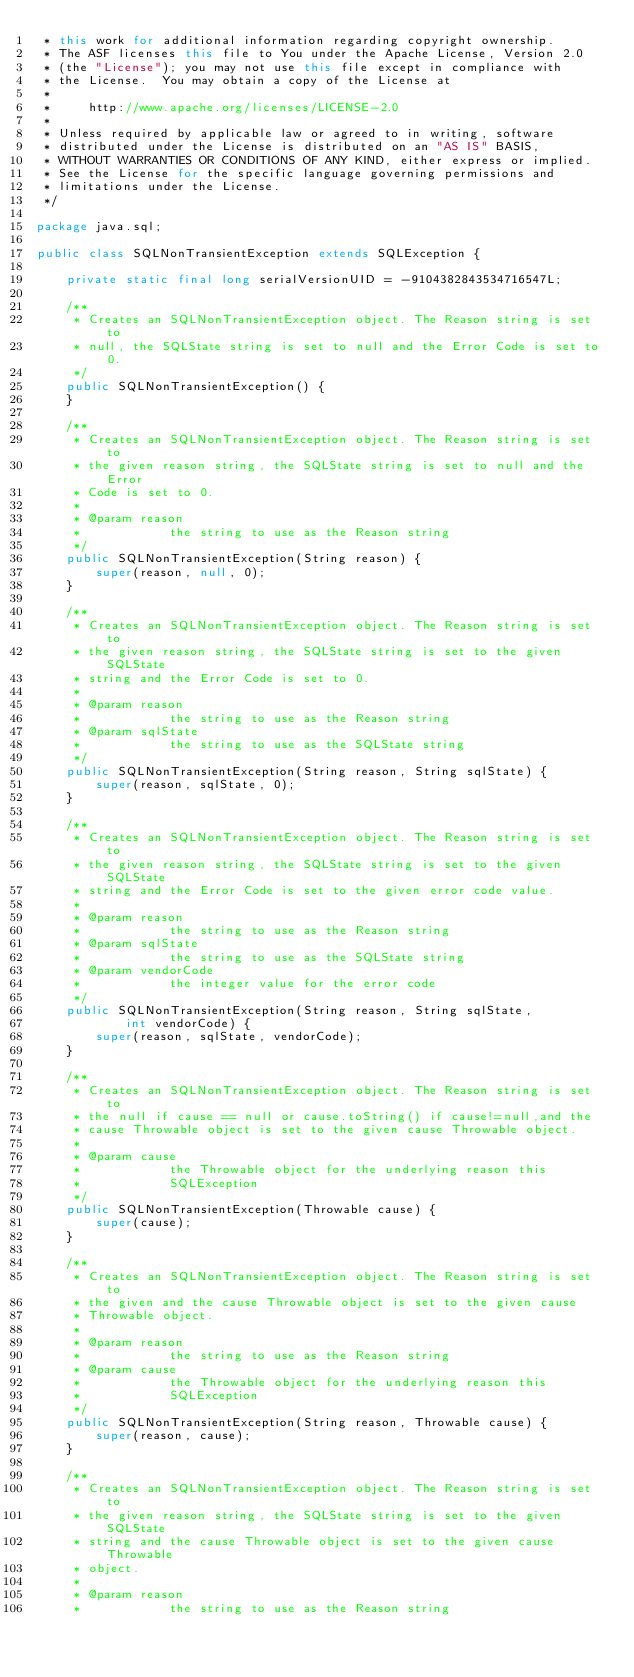<code> <loc_0><loc_0><loc_500><loc_500><_Java_> * this work for additional information regarding copyright ownership.
 * The ASF licenses this file to You under the Apache License, Version 2.0
 * (the "License"); you may not use this file except in compliance with
 * the License.  You may obtain a copy of the License at
 *
 *     http://www.apache.org/licenses/LICENSE-2.0
 *
 * Unless required by applicable law or agreed to in writing, software
 * distributed under the License is distributed on an "AS IS" BASIS,
 * WITHOUT WARRANTIES OR CONDITIONS OF ANY KIND, either express or implied.
 * See the License for the specific language governing permissions and
 * limitations under the License.
 */

package java.sql;

public class SQLNonTransientException extends SQLException {

    private static final long serialVersionUID = -9104382843534716547L;

    /**
     * Creates an SQLNonTransientException object. The Reason string is set to
     * null, the SQLState string is set to null and the Error Code is set to 0.
     */
    public SQLNonTransientException() {
    }

    /**
     * Creates an SQLNonTransientException object. The Reason string is set to
     * the given reason string, the SQLState string is set to null and the Error
     * Code is set to 0.
     *
     * @param reason
     *            the string to use as the Reason string
     */
    public SQLNonTransientException(String reason) {
        super(reason, null, 0);
    }

    /**
     * Creates an SQLNonTransientException object. The Reason string is set to
     * the given reason string, the SQLState string is set to the given SQLState
     * string and the Error Code is set to 0.
     *
     * @param reason
     *            the string to use as the Reason string
     * @param sqlState
     *            the string to use as the SQLState string
     */
    public SQLNonTransientException(String reason, String sqlState) {
        super(reason, sqlState, 0);
    }

    /**
     * Creates an SQLNonTransientException object. The Reason string is set to
     * the given reason string, the SQLState string is set to the given SQLState
     * string and the Error Code is set to the given error code value.
     *
     * @param reason
     *            the string to use as the Reason string
     * @param sqlState
     *            the string to use as the SQLState string
     * @param vendorCode
     *            the integer value for the error code
     */
    public SQLNonTransientException(String reason, String sqlState,
            int vendorCode) {
        super(reason, sqlState, vendorCode);
    }

    /**
     * Creates an SQLNonTransientException object. The Reason string is set to
     * the null if cause == null or cause.toString() if cause!=null,and the
     * cause Throwable object is set to the given cause Throwable object.
     *
     * @param cause
     *            the Throwable object for the underlying reason this
     *            SQLException
     */
    public SQLNonTransientException(Throwable cause) {
        super(cause);
    }

    /**
     * Creates an SQLNonTransientException object. The Reason string is set to
     * the given and the cause Throwable object is set to the given cause
     * Throwable object.
     *
     * @param reason
     *            the string to use as the Reason string
     * @param cause
     *            the Throwable object for the underlying reason this
     *            SQLException
     */
    public SQLNonTransientException(String reason, Throwable cause) {
        super(reason, cause);
    }

    /**
     * Creates an SQLNonTransientException object. The Reason string is set to
     * the given reason string, the SQLState string is set to the given SQLState
     * string and the cause Throwable object is set to the given cause Throwable
     * object.
     *
     * @param reason
     *            the string to use as the Reason string</code> 